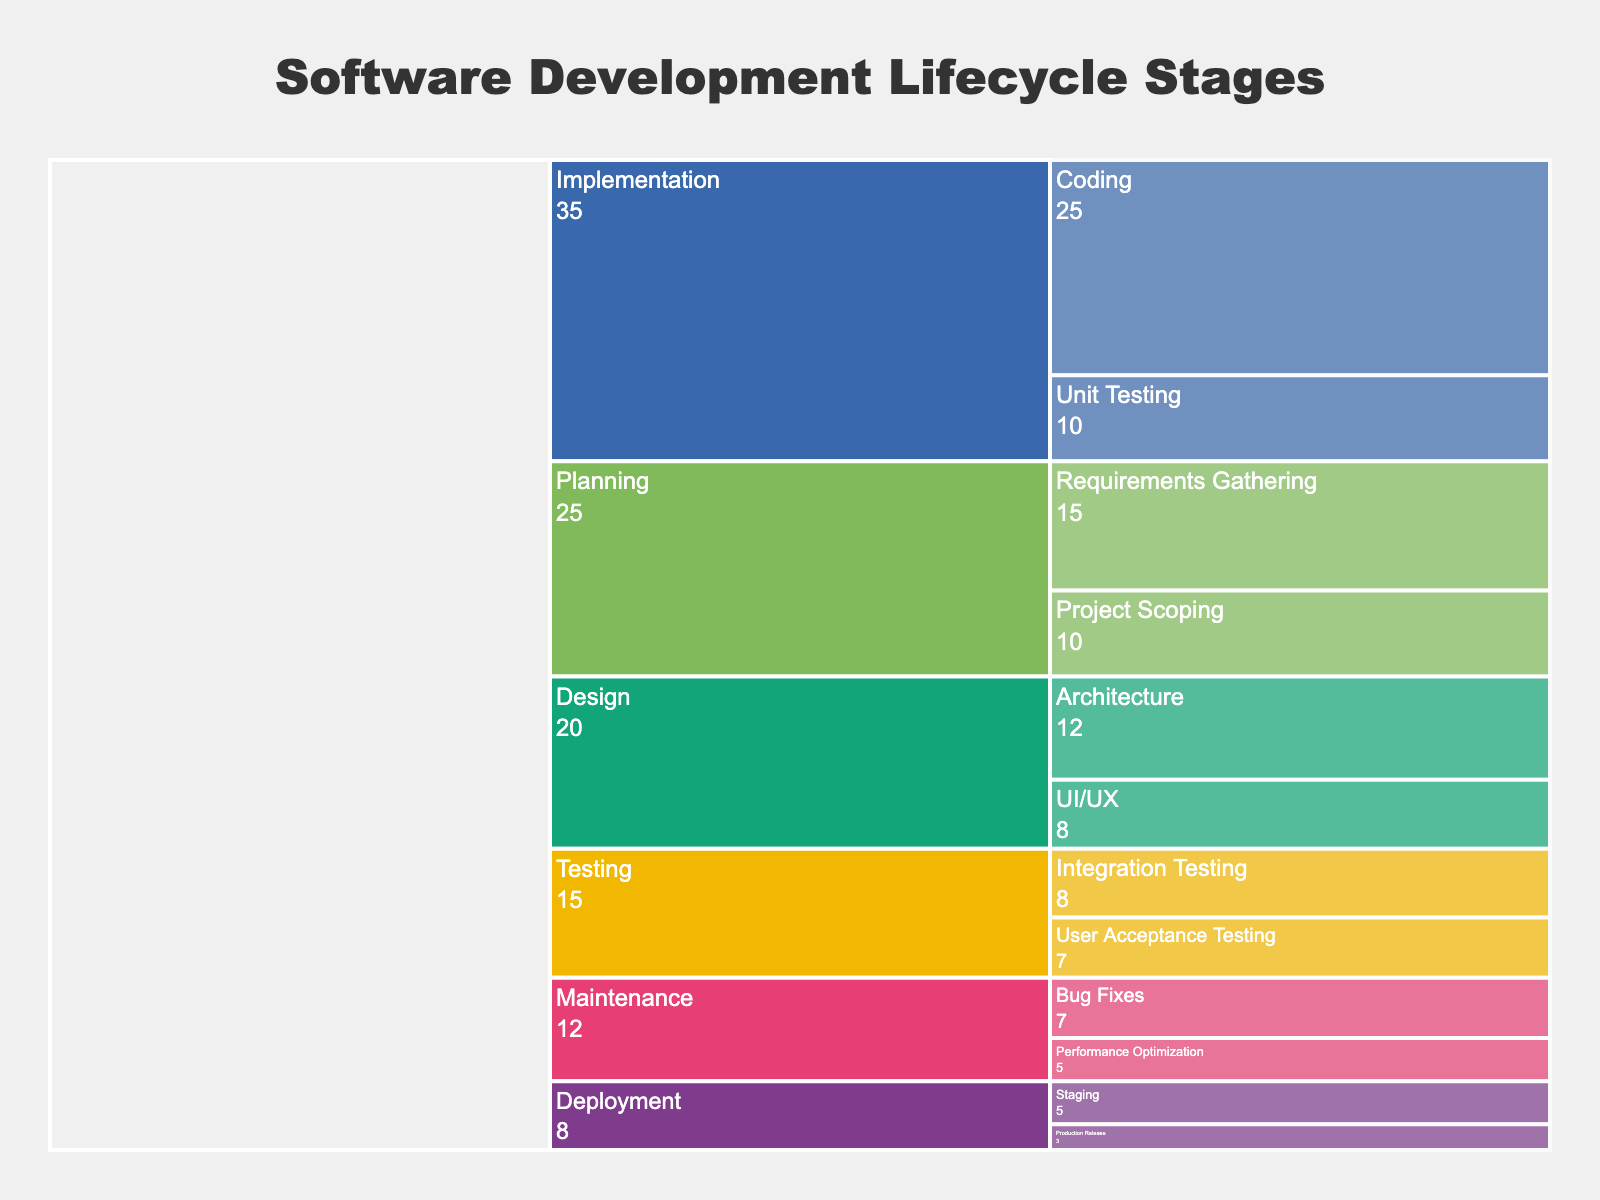What is the title of the chart? The title is typically displayed at the top of the chart in a larger font. In this case, it is 'Software Development Lifecycle Stages' as specified in the code.
Answer: Software Development Lifecycle Stages Which stage has the maximum time allocation? To find this out, you need to look for the stage that has the largest visual representation or the highest sum of its sub-stages' time allocations. 'Implementation' has the highest value at 35 units (25 for Coding + 10 for Unit Testing).
Answer: Implementation What is the combined time allocation for the Planning stage? Add the time values of all sub-stages within the Planning stage. So, it's 15 (Requirements Gathering) + 10 (Project Scoping) = 25 units.
Answer: 25 units Which has more time allocated: UI/UX design or Bug Fixes? Compare the specific values: UI/UX has 8 units, while Bug Fixes have 7 units. Therefore, UI/UX has more time allocated.
Answer: UI/UX design What is the total time allocated to Testing? Sum the time values for all sub-stages under the Testing stage: 8 (Integration Testing) + 7 (User Acceptance Testing) = 15 units.
Answer: 15 units How does the time allocated to Requirements Gathering compare to Performance Optimization? Requirements Gathering has 15 units, whereas Performance Optimization has 5 units, so Requirements Gathering is greater.
Answer: Requirements Gathering Which stage has the least time allocated? Look for the stage with the smallest visual representation or sum of time values. 'Deployment' has the least time allocation at 8 units (5 for Staging + 3 for Production Release).
Answer: Deployment How much more time is allocated to Coding compared to Unit Testing? Subtract the time value of Unit Testing from that of Coding: 25 (Coding) - 10 (Unit Testing) = 15 units.
Answer: 15 units What is the average time allocation per sub-stage? First, sum all time allocations: 15 + 10 + 12 + 8 + 25 + 10 + 8 + 7 + 5 + 3 + 7 + 5 = 115 units. Then, divide by the number of sub-stages, which is 12. So the average is 115 / 12 ≈ 9.58 units.
Answer: Approximately 9.58 units Is the time allocated to Project Scoping greater than or equal to User Acceptance Testing? Compare the values: Project Scoping has 10 units, and User Acceptance Testing has 7 units. Therefore, Project Scoping is greater.
Answer: Yes 